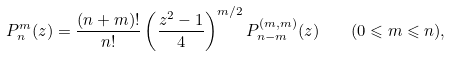<formula> <loc_0><loc_0><loc_500><loc_500>P _ { n } ^ { m } ( z ) = \frac { ( n + m ) ! } { n ! } \left ( \frac { z ^ { 2 } - 1 } { 4 } \right ) ^ { m / 2 } P _ { n - m } ^ { ( m , m ) } ( z ) \quad ( 0 \leqslant m \leqslant n ) ,</formula> 